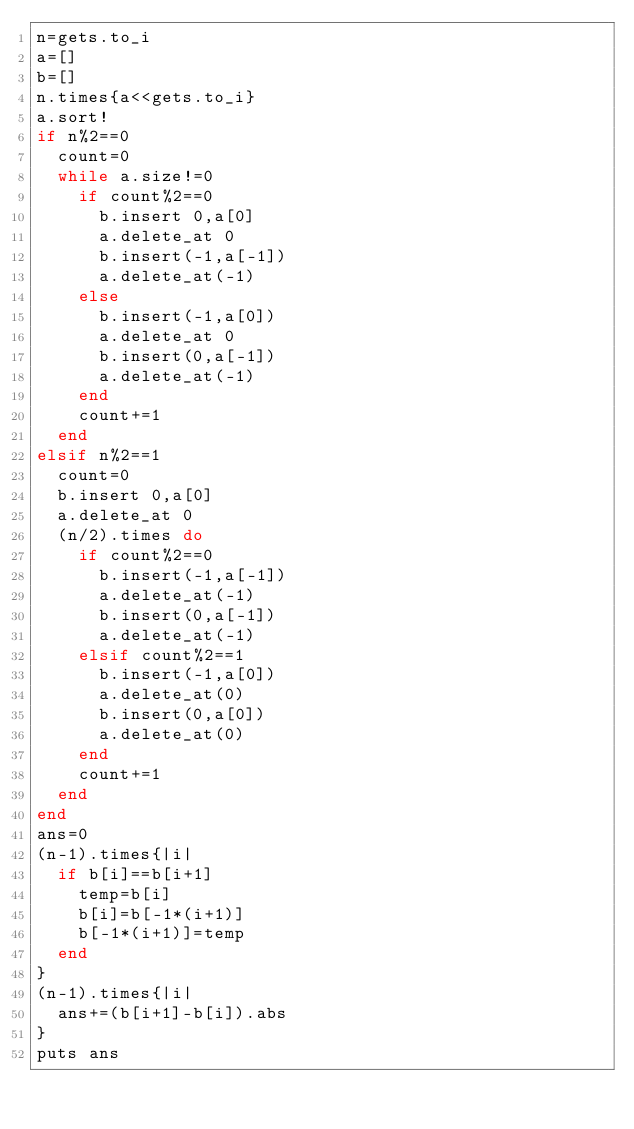<code> <loc_0><loc_0><loc_500><loc_500><_Ruby_>n=gets.to_i
a=[]
b=[]
n.times{a<<gets.to_i}
a.sort!
if n%2==0
  count=0
  while a.size!=0
    if count%2==0
      b.insert 0,a[0]
      a.delete_at 0
      b.insert(-1,a[-1])
      a.delete_at(-1)
    else
      b.insert(-1,a[0])
      a.delete_at 0
      b.insert(0,a[-1])
      a.delete_at(-1)
    end
    count+=1
  end
elsif n%2==1
  count=0
  b.insert 0,a[0]
  a.delete_at 0
  (n/2).times do
    if count%2==0
      b.insert(-1,a[-1])
      a.delete_at(-1)
      b.insert(0,a[-1])
      a.delete_at(-1)
    elsif count%2==1
      b.insert(-1,a[0])
      a.delete_at(0)
      b.insert(0,a[0])
      a.delete_at(0)
    end
    count+=1
  end
end
ans=0
(n-1).times{|i|
  if b[i]==b[i+1]
    temp=b[i]
    b[i]=b[-1*(i+1)]
    b[-1*(i+1)]=temp
  end
}
(n-1).times{|i|
  ans+=(b[i+1]-b[i]).abs
}
puts ans</code> 